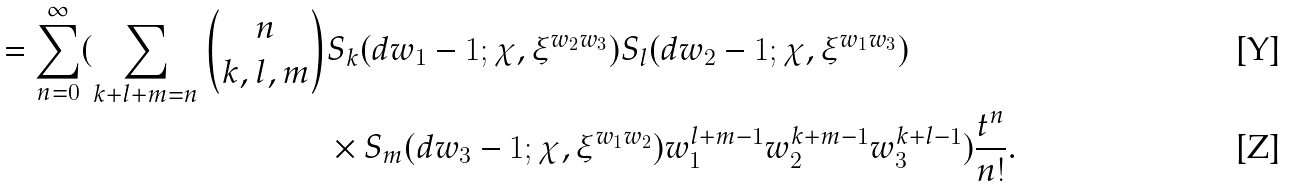Convert formula to latex. <formula><loc_0><loc_0><loc_500><loc_500>= \sum _ { n = 0 } ^ { \infty } ( \sum _ { k + l + m = n } \binom { n } { k , l , m } & S _ { k } ( d w _ { 1 } - 1 ; \chi , \xi ^ { w _ { 2 } w _ { 3 } } ) S _ { l } ( d w _ { 2 } - 1 ; \chi , \xi ^ { w _ { 1 } w _ { 3 } } ) \\ & \times S _ { m } ( d w _ { 3 } - 1 ; \chi , \xi ^ { w _ { 1 } w _ { 2 } } ) w _ { 1 } ^ { l + m - 1 } w _ { 2 } ^ { k + m - 1 } w _ { 3 } ^ { k + l - 1 } ) \frac { t ^ { n } } { n ! } .</formula> 